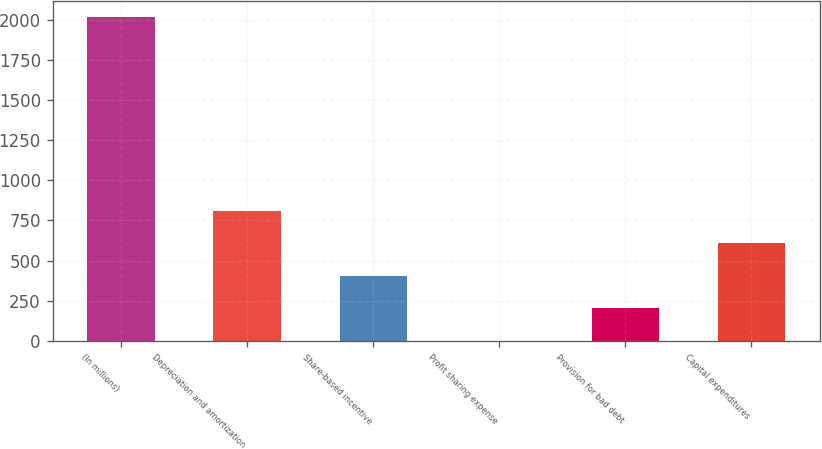Convert chart. <chart><loc_0><loc_0><loc_500><loc_500><bar_chart><fcel>(In millions)<fcel>Depreciation and amortization<fcel>Share-based incentive<fcel>Profit sharing expense<fcel>Provision for bad debt<fcel>Capital expenditures<nl><fcel>2016<fcel>808.14<fcel>405.52<fcel>2.9<fcel>204.21<fcel>606.83<nl></chart> 